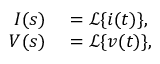Convert formula to latex. <formula><loc_0><loc_0><loc_500><loc_500>\begin{array} { r l } { I ( s ) } & = { \mathcal { L } } \{ i ( t ) \} , } \\ { V ( s ) } & = { \mathcal { L } } \{ v ( t ) \} , } \end{array}</formula> 